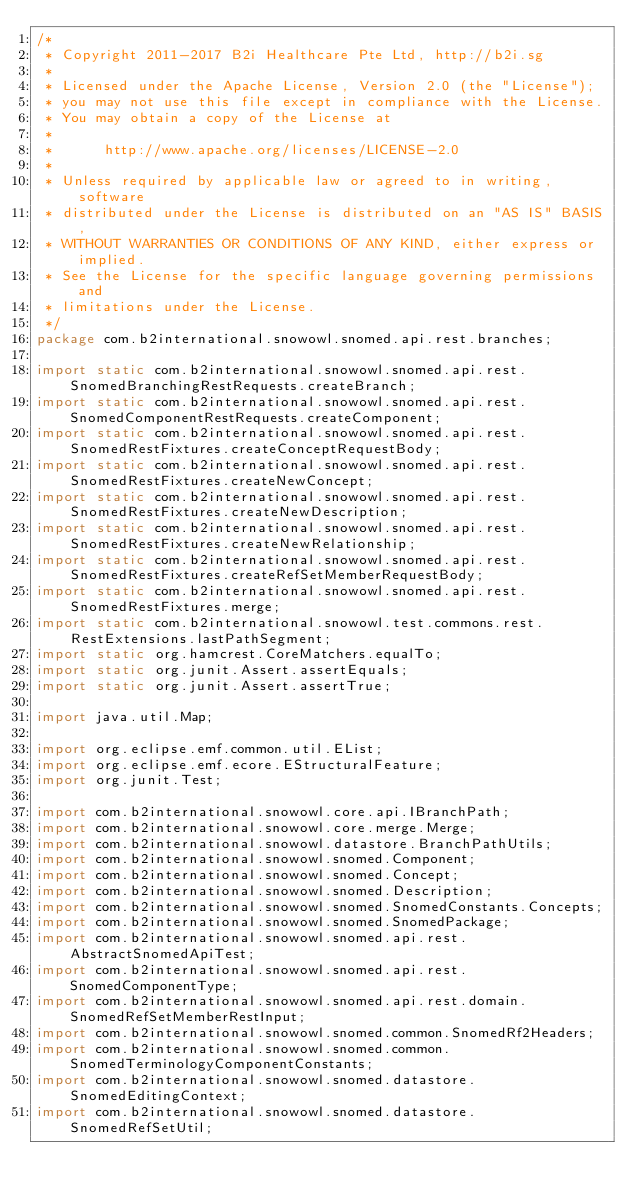Convert code to text. <code><loc_0><loc_0><loc_500><loc_500><_Java_>/*
 * Copyright 2011-2017 B2i Healthcare Pte Ltd, http://b2i.sg
 * 
 * Licensed under the Apache License, Version 2.0 (the "License");
 * you may not use this file except in compliance with the License.
 * You may obtain a copy of the License at
 *
 *      http://www.apache.org/licenses/LICENSE-2.0
 *
 * Unless required by applicable law or agreed to in writing, software
 * distributed under the License is distributed on an "AS IS" BASIS,
 * WITHOUT WARRANTIES OR CONDITIONS OF ANY KIND, either express or implied.
 * See the License for the specific language governing permissions and
 * limitations under the License.
 */
package com.b2international.snowowl.snomed.api.rest.branches;

import static com.b2international.snowowl.snomed.api.rest.SnomedBranchingRestRequests.createBranch;
import static com.b2international.snowowl.snomed.api.rest.SnomedComponentRestRequests.createComponent;
import static com.b2international.snowowl.snomed.api.rest.SnomedRestFixtures.createConceptRequestBody;
import static com.b2international.snowowl.snomed.api.rest.SnomedRestFixtures.createNewConcept;
import static com.b2international.snowowl.snomed.api.rest.SnomedRestFixtures.createNewDescription;
import static com.b2international.snowowl.snomed.api.rest.SnomedRestFixtures.createNewRelationship;
import static com.b2international.snowowl.snomed.api.rest.SnomedRestFixtures.createRefSetMemberRequestBody;
import static com.b2international.snowowl.snomed.api.rest.SnomedRestFixtures.merge;
import static com.b2international.snowowl.test.commons.rest.RestExtensions.lastPathSegment;
import static org.hamcrest.CoreMatchers.equalTo;
import static org.junit.Assert.assertEquals;
import static org.junit.Assert.assertTrue;

import java.util.Map;

import org.eclipse.emf.common.util.EList;
import org.eclipse.emf.ecore.EStructuralFeature;
import org.junit.Test;

import com.b2international.snowowl.core.api.IBranchPath;
import com.b2international.snowowl.core.merge.Merge;
import com.b2international.snowowl.datastore.BranchPathUtils;
import com.b2international.snowowl.snomed.Component;
import com.b2international.snowowl.snomed.Concept;
import com.b2international.snowowl.snomed.Description;
import com.b2international.snowowl.snomed.SnomedConstants.Concepts;
import com.b2international.snowowl.snomed.SnomedPackage;
import com.b2international.snowowl.snomed.api.rest.AbstractSnomedApiTest;
import com.b2international.snowowl.snomed.api.rest.SnomedComponentType;
import com.b2international.snowowl.snomed.api.rest.domain.SnomedRefSetMemberRestInput;
import com.b2international.snowowl.snomed.common.SnomedRf2Headers;
import com.b2international.snowowl.snomed.common.SnomedTerminologyComponentConstants;
import com.b2international.snowowl.snomed.datastore.SnomedEditingContext;
import com.b2international.snowowl.snomed.datastore.SnomedRefSetUtil;</code> 